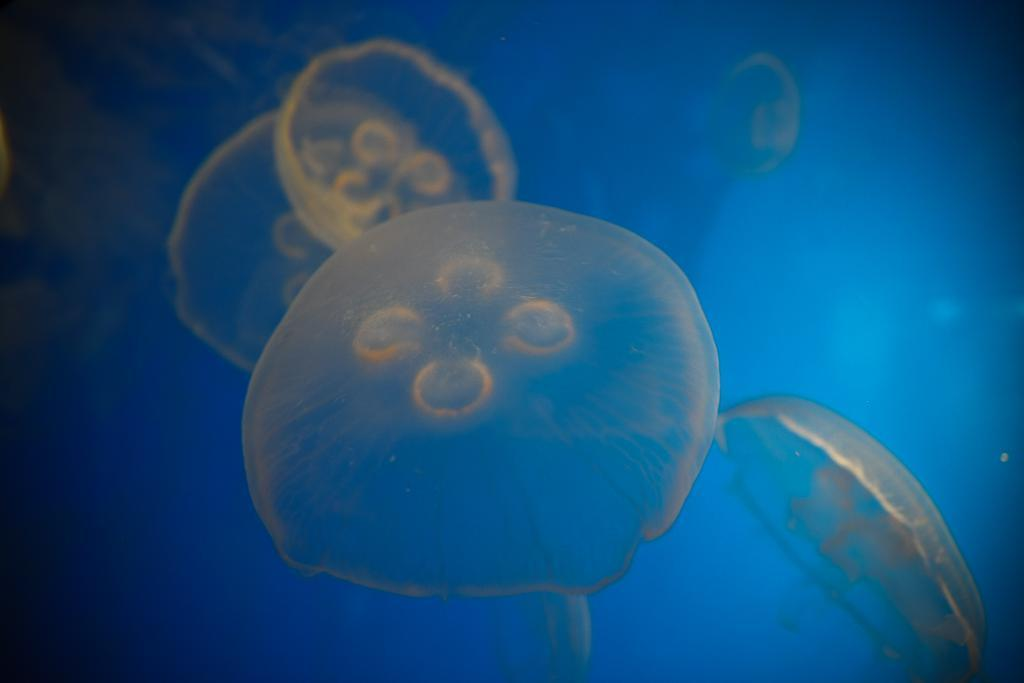What type of animals can be seen in the water in the image? There are jellyfishes in the water in the image. What color is the background of the image? The background of the image is blue. What type of twig can be seen floating in the water with the jellyfishes? There is no twig present in the image; only jellyfishes are visible in the water. What kind of soap is being used during the protest in the image? There is no protest or soap present in the image; it features jellyfishes in the water with a blue background. 